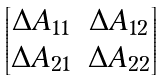<formula> <loc_0><loc_0><loc_500><loc_500>\begin{bmatrix} \Delta A _ { 1 1 } & \Delta A _ { 1 2 } \\ \Delta A _ { 2 1 } & \Delta A _ { 2 2 } \\ \end{bmatrix}</formula> 